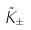<formula> <loc_0><loc_0><loc_500><loc_500>\tilde { K } _ { \pm }</formula> 